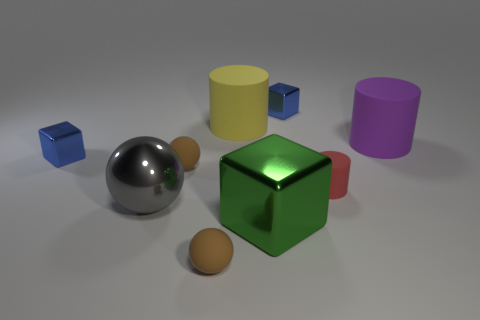How many other things are the same color as the large block?
Offer a terse response. 0. There is a brown rubber sphere in front of the red rubber cylinder; does it have the same size as the cylinder that is in front of the large purple rubber object?
Keep it short and to the point. Yes. Is the large green object made of the same material as the brown sphere that is behind the large gray shiny sphere?
Your answer should be very brief. No. Are there more tiny blue metallic objects right of the big yellow object than small cubes on the right side of the big purple matte thing?
Your answer should be very brief. Yes. The small shiny cube right of the large cylinder on the left side of the green object is what color?
Provide a short and direct response. Blue. How many cylinders are either cyan rubber objects or small red rubber things?
Your answer should be compact. 1. What number of rubber objects are behind the red rubber object and on the left side of the tiny red cylinder?
Keep it short and to the point. 2. There is a large cylinder that is to the left of the tiny cylinder; what color is it?
Your response must be concise. Yellow. There is a green cube that is made of the same material as the gray sphere; what is its size?
Your answer should be very brief. Large. How many green objects are on the left side of the large metal block that is on the right side of the big shiny ball?
Ensure brevity in your answer.  0. 